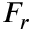<formula> <loc_0><loc_0><loc_500><loc_500>F _ { r }</formula> 